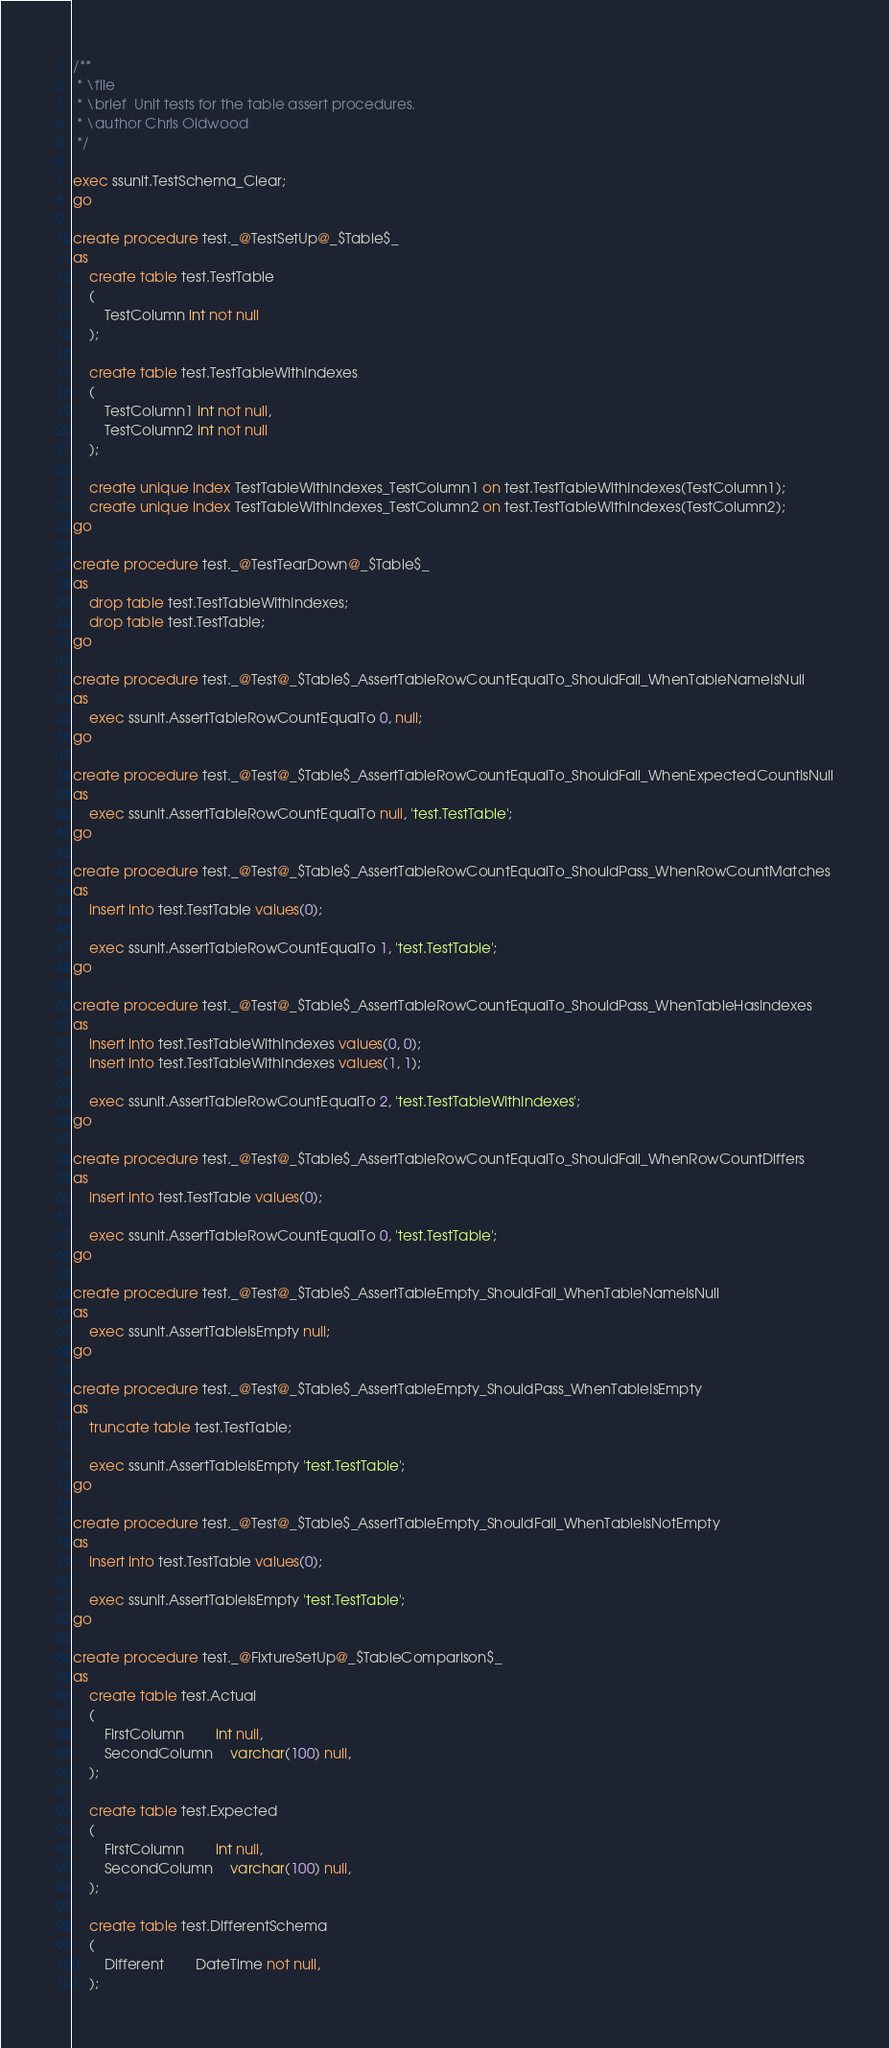<code> <loc_0><loc_0><loc_500><loc_500><_SQL_>/**
 * \file
 * \brief  Unit tests for the table assert procedures.
 * \author Chris Oldwood
 */

exec ssunit.TestSchema_Clear;
go

create procedure test._@TestSetUp@_$Table$_
as
	create table test.TestTable
	(
		TestColumn int not null
	);

	create table test.TestTableWithIndexes
	(
		TestColumn1 int not null,
		TestColumn2 int not null
	);

	create unique index TestTableWithIndexes_TestColumn1 on test.TestTableWithIndexes(TestColumn1);
	create unique index TestTableWithIndexes_TestColumn2 on test.TestTableWithIndexes(TestColumn2);
go

create procedure test._@TestTearDown@_$Table$_
as
	drop table test.TestTableWithIndexes;
	drop table test.TestTable;
go

create procedure test._@Test@_$Table$_AssertTableRowCountEqualTo_ShouldFail_WhenTableNameIsNull
as
	exec ssunit.AssertTableRowCountEqualTo 0, null;
go

create procedure test._@Test@_$Table$_AssertTableRowCountEqualTo_ShouldFail_WhenExpectedCountIsNull
as
	exec ssunit.AssertTableRowCountEqualTo null, 'test.TestTable';
go

create procedure test._@Test@_$Table$_AssertTableRowCountEqualTo_ShouldPass_WhenRowCountMatches
as
	insert into test.TestTable values(0);

	exec ssunit.AssertTableRowCountEqualTo 1, 'test.TestTable';
go

create procedure test._@Test@_$Table$_AssertTableRowCountEqualTo_ShouldPass_WhenTableHasIndexes
as
	insert into test.TestTableWithIndexes values(0, 0);
	insert into test.TestTableWithIndexes values(1, 1);

	exec ssunit.AssertTableRowCountEqualTo 2, 'test.TestTableWithIndexes';
go

create procedure test._@Test@_$Table$_AssertTableRowCountEqualTo_ShouldFail_WhenRowCountDiffers
as
	insert into test.TestTable values(0);

	exec ssunit.AssertTableRowCountEqualTo 0, 'test.TestTable';
go

create procedure test._@Test@_$Table$_AssertTableEmpty_ShouldFail_WhenTableNameIsNull
as
	exec ssunit.AssertTableIsEmpty null;
go

create procedure test._@Test@_$Table$_AssertTableEmpty_ShouldPass_WhenTableIsEmpty
as
	truncate table test.TestTable;

	exec ssunit.AssertTableIsEmpty 'test.TestTable';
go

create procedure test._@Test@_$Table$_AssertTableEmpty_ShouldFail_WhenTableIsNotEmpty
as
	insert into test.TestTable values(0);

	exec ssunit.AssertTableIsEmpty 'test.TestTable';
go

create procedure test._@FixtureSetUp@_$TableComparison$_
as
	create table test.Actual
	(
		FirstColumn		int null,
		SecondColumn	varchar(100) null,
	);

	create table test.Expected
	(
		FirstColumn		int null,
		SecondColumn	varchar(100) null,
	);

	create table test.DifferentSchema
	(
		Different		DateTime not null,
	);</code> 